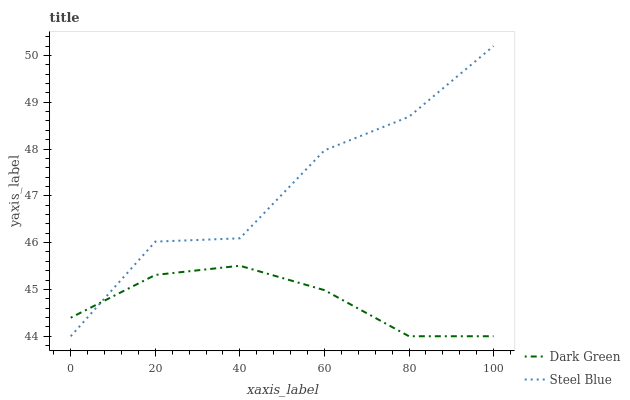Does Dark Green have the minimum area under the curve?
Answer yes or no. Yes. Does Steel Blue have the maximum area under the curve?
Answer yes or no. Yes. Does Dark Green have the maximum area under the curve?
Answer yes or no. No. Is Dark Green the smoothest?
Answer yes or no. Yes. Is Steel Blue the roughest?
Answer yes or no. Yes. Is Dark Green the roughest?
Answer yes or no. No. Does Steel Blue have the highest value?
Answer yes or no. Yes. Does Dark Green have the highest value?
Answer yes or no. No. Does Dark Green intersect Steel Blue?
Answer yes or no. Yes. Is Dark Green less than Steel Blue?
Answer yes or no. No. Is Dark Green greater than Steel Blue?
Answer yes or no. No. 